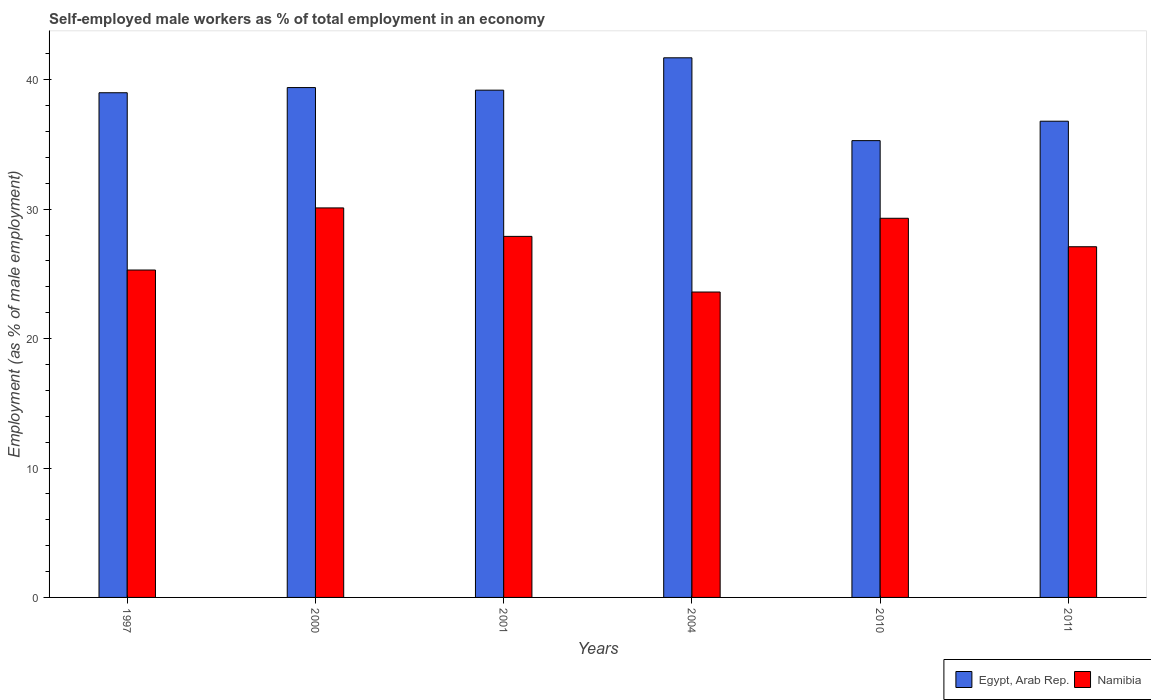How many different coloured bars are there?
Ensure brevity in your answer.  2. Are the number of bars per tick equal to the number of legend labels?
Ensure brevity in your answer.  Yes. How many bars are there on the 1st tick from the left?
Offer a terse response. 2. How many bars are there on the 2nd tick from the right?
Ensure brevity in your answer.  2. What is the label of the 1st group of bars from the left?
Ensure brevity in your answer.  1997. What is the percentage of self-employed male workers in Egypt, Arab Rep. in 2001?
Offer a terse response. 39.2. Across all years, what is the maximum percentage of self-employed male workers in Egypt, Arab Rep.?
Your response must be concise. 41.7. Across all years, what is the minimum percentage of self-employed male workers in Namibia?
Your answer should be very brief. 23.6. What is the total percentage of self-employed male workers in Namibia in the graph?
Offer a terse response. 163.3. What is the difference between the percentage of self-employed male workers in Namibia in 2011 and the percentage of self-employed male workers in Egypt, Arab Rep. in 2010?
Your answer should be very brief. -8.2. What is the average percentage of self-employed male workers in Namibia per year?
Ensure brevity in your answer.  27.22. In the year 2001, what is the difference between the percentage of self-employed male workers in Egypt, Arab Rep. and percentage of self-employed male workers in Namibia?
Provide a short and direct response. 11.3. What is the ratio of the percentage of self-employed male workers in Egypt, Arab Rep. in 2004 to that in 2011?
Offer a terse response. 1.13. Is the percentage of self-employed male workers in Namibia in 1997 less than that in 2010?
Your response must be concise. Yes. Is the difference between the percentage of self-employed male workers in Egypt, Arab Rep. in 1997 and 2004 greater than the difference between the percentage of self-employed male workers in Namibia in 1997 and 2004?
Give a very brief answer. No. What is the difference between the highest and the second highest percentage of self-employed male workers in Namibia?
Your response must be concise. 0.8. What is the difference between the highest and the lowest percentage of self-employed male workers in Namibia?
Your response must be concise. 6.5. In how many years, is the percentage of self-employed male workers in Egypt, Arab Rep. greater than the average percentage of self-employed male workers in Egypt, Arab Rep. taken over all years?
Offer a very short reply. 4. Is the sum of the percentage of self-employed male workers in Namibia in 2000 and 2010 greater than the maximum percentage of self-employed male workers in Egypt, Arab Rep. across all years?
Provide a short and direct response. Yes. What does the 1st bar from the left in 2000 represents?
Keep it short and to the point. Egypt, Arab Rep. What does the 2nd bar from the right in 1997 represents?
Make the answer very short. Egypt, Arab Rep. How many bars are there?
Make the answer very short. 12. How many years are there in the graph?
Your answer should be very brief. 6. Where does the legend appear in the graph?
Offer a terse response. Bottom right. How are the legend labels stacked?
Give a very brief answer. Horizontal. What is the title of the graph?
Ensure brevity in your answer.  Self-employed male workers as % of total employment in an economy. What is the label or title of the X-axis?
Keep it short and to the point. Years. What is the label or title of the Y-axis?
Your response must be concise. Employment (as % of male employment). What is the Employment (as % of male employment) in Egypt, Arab Rep. in 1997?
Offer a very short reply. 39. What is the Employment (as % of male employment) in Namibia in 1997?
Give a very brief answer. 25.3. What is the Employment (as % of male employment) of Egypt, Arab Rep. in 2000?
Offer a terse response. 39.4. What is the Employment (as % of male employment) of Namibia in 2000?
Your response must be concise. 30.1. What is the Employment (as % of male employment) of Egypt, Arab Rep. in 2001?
Your answer should be very brief. 39.2. What is the Employment (as % of male employment) in Namibia in 2001?
Make the answer very short. 27.9. What is the Employment (as % of male employment) of Egypt, Arab Rep. in 2004?
Offer a very short reply. 41.7. What is the Employment (as % of male employment) in Namibia in 2004?
Offer a terse response. 23.6. What is the Employment (as % of male employment) in Egypt, Arab Rep. in 2010?
Make the answer very short. 35.3. What is the Employment (as % of male employment) in Namibia in 2010?
Keep it short and to the point. 29.3. What is the Employment (as % of male employment) in Egypt, Arab Rep. in 2011?
Offer a terse response. 36.8. What is the Employment (as % of male employment) of Namibia in 2011?
Give a very brief answer. 27.1. Across all years, what is the maximum Employment (as % of male employment) of Egypt, Arab Rep.?
Offer a very short reply. 41.7. Across all years, what is the maximum Employment (as % of male employment) in Namibia?
Offer a terse response. 30.1. Across all years, what is the minimum Employment (as % of male employment) in Egypt, Arab Rep.?
Ensure brevity in your answer.  35.3. Across all years, what is the minimum Employment (as % of male employment) of Namibia?
Give a very brief answer. 23.6. What is the total Employment (as % of male employment) in Egypt, Arab Rep. in the graph?
Provide a succinct answer. 231.4. What is the total Employment (as % of male employment) in Namibia in the graph?
Offer a very short reply. 163.3. What is the difference between the Employment (as % of male employment) in Namibia in 1997 and that in 2000?
Your answer should be compact. -4.8. What is the difference between the Employment (as % of male employment) in Egypt, Arab Rep. in 1997 and that in 2001?
Offer a very short reply. -0.2. What is the difference between the Employment (as % of male employment) in Namibia in 1997 and that in 2001?
Give a very brief answer. -2.6. What is the difference between the Employment (as % of male employment) in Egypt, Arab Rep. in 1997 and that in 2004?
Your response must be concise. -2.7. What is the difference between the Employment (as % of male employment) in Egypt, Arab Rep. in 1997 and that in 2010?
Provide a short and direct response. 3.7. What is the difference between the Employment (as % of male employment) in Egypt, Arab Rep. in 1997 and that in 2011?
Provide a succinct answer. 2.2. What is the difference between the Employment (as % of male employment) in Egypt, Arab Rep. in 2000 and that in 2004?
Make the answer very short. -2.3. What is the difference between the Employment (as % of male employment) in Namibia in 2000 and that in 2004?
Offer a terse response. 6.5. What is the difference between the Employment (as % of male employment) in Namibia in 2000 and that in 2010?
Offer a terse response. 0.8. What is the difference between the Employment (as % of male employment) of Namibia in 2000 and that in 2011?
Provide a succinct answer. 3. What is the difference between the Employment (as % of male employment) of Namibia in 2001 and that in 2004?
Keep it short and to the point. 4.3. What is the difference between the Employment (as % of male employment) in Egypt, Arab Rep. in 2001 and that in 2010?
Keep it short and to the point. 3.9. What is the difference between the Employment (as % of male employment) in Namibia in 2001 and that in 2010?
Make the answer very short. -1.4. What is the difference between the Employment (as % of male employment) in Egypt, Arab Rep. in 2001 and that in 2011?
Ensure brevity in your answer.  2.4. What is the difference between the Employment (as % of male employment) in Namibia in 2001 and that in 2011?
Make the answer very short. 0.8. What is the difference between the Employment (as % of male employment) in Namibia in 2004 and that in 2011?
Offer a very short reply. -3.5. What is the difference between the Employment (as % of male employment) of Egypt, Arab Rep. in 1997 and the Employment (as % of male employment) of Namibia in 2001?
Offer a terse response. 11.1. What is the difference between the Employment (as % of male employment) of Egypt, Arab Rep. in 1997 and the Employment (as % of male employment) of Namibia in 2004?
Offer a terse response. 15.4. What is the difference between the Employment (as % of male employment) of Egypt, Arab Rep. in 2000 and the Employment (as % of male employment) of Namibia in 2004?
Provide a succinct answer. 15.8. What is the difference between the Employment (as % of male employment) in Egypt, Arab Rep. in 2000 and the Employment (as % of male employment) in Namibia in 2010?
Give a very brief answer. 10.1. What is the difference between the Employment (as % of male employment) of Egypt, Arab Rep. in 2000 and the Employment (as % of male employment) of Namibia in 2011?
Ensure brevity in your answer.  12.3. What is the difference between the Employment (as % of male employment) of Egypt, Arab Rep. in 2001 and the Employment (as % of male employment) of Namibia in 2011?
Provide a short and direct response. 12.1. What is the difference between the Employment (as % of male employment) in Egypt, Arab Rep. in 2004 and the Employment (as % of male employment) in Namibia in 2010?
Your answer should be compact. 12.4. What is the difference between the Employment (as % of male employment) in Egypt, Arab Rep. in 2004 and the Employment (as % of male employment) in Namibia in 2011?
Make the answer very short. 14.6. What is the average Employment (as % of male employment) in Egypt, Arab Rep. per year?
Your answer should be very brief. 38.57. What is the average Employment (as % of male employment) in Namibia per year?
Give a very brief answer. 27.22. In the year 2010, what is the difference between the Employment (as % of male employment) in Egypt, Arab Rep. and Employment (as % of male employment) in Namibia?
Keep it short and to the point. 6. What is the ratio of the Employment (as % of male employment) in Namibia in 1997 to that in 2000?
Your answer should be compact. 0.84. What is the ratio of the Employment (as % of male employment) of Egypt, Arab Rep. in 1997 to that in 2001?
Offer a terse response. 0.99. What is the ratio of the Employment (as % of male employment) in Namibia in 1997 to that in 2001?
Offer a very short reply. 0.91. What is the ratio of the Employment (as % of male employment) in Egypt, Arab Rep. in 1997 to that in 2004?
Give a very brief answer. 0.94. What is the ratio of the Employment (as % of male employment) of Namibia in 1997 to that in 2004?
Give a very brief answer. 1.07. What is the ratio of the Employment (as % of male employment) in Egypt, Arab Rep. in 1997 to that in 2010?
Provide a short and direct response. 1.1. What is the ratio of the Employment (as % of male employment) in Namibia in 1997 to that in 2010?
Your response must be concise. 0.86. What is the ratio of the Employment (as % of male employment) in Egypt, Arab Rep. in 1997 to that in 2011?
Make the answer very short. 1.06. What is the ratio of the Employment (as % of male employment) of Namibia in 1997 to that in 2011?
Offer a terse response. 0.93. What is the ratio of the Employment (as % of male employment) of Namibia in 2000 to that in 2001?
Offer a terse response. 1.08. What is the ratio of the Employment (as % of male employment) in Egypt, Arab Rep. in 2000 to that in 2004?
Provide a succinct answer. 0.94. What is the ratio of the Employment (as % of male employment) of Namibia in 2000 to that in 2004?
Ensure brevity in your answer.  1.28. What is the ratio of the Employment (as % of male employment) in Egypt, Arab Rep. in 2000 to that in 2010?
Provide a short and direct response. 1.12. What is the ratio of the Employment (as % of male employment) in Namibia in 2000 to that in 2010?
Ensure brevity in your answer.  1.03. What is the ratio of the Employment (as % of male employment) of Egypt, Arab Rep. in 2000 to that in 2011?
Make the answer very short. 1.07. What is the ratio of the Employment (as % of male employment) of Namibia in 2000 to that in 2011?
Offer a very short reply. 1.11. What is the ratio of the Employment (as % of male employment) in Egypt, Arab Rep. in 2001 to that in 2004?
Your answer should be compact. 0.94. What is the ratio of the Employment (as % of male employment) in Namibia in 2001 to that in 2004?
Offer a very short reply. 1.18. What is the ratio of the Employment (as % of male employment) of Egypt, Arab Rep. in 2001 to that in 2010?
Offer a terse response. 1.11. What is the ratio of the Employment (as % of male employment) of Namibia in 2001 to that in 2010?
Your answer should be compact. 0.95. What is the ratio of the Employment (as % of male employment) in Egypt, Arab Rep. in 2001 to that in 2011?
Make the answer very short. 1.07. What is the ratio of the Employment (as % of male employment) in Namibia in 2001 to that in 2011?
Make the answer very short. 1.03. What is the ratio of the Employment (as % of male employment) in Egypt, Arab Rep. in 2004 to that in 2010?
Offer a very short reply. 1.18. What is the ratio of the Employment (as % of male employment) of Namibia in 2004 to that in 2010?
Ensure brevity in your answer.  0.81. What is the ratio of the Employment (as % of male employment) in Egypt, Arab Rep. in 2004 to that in 2011?
Your response must be concise. 1.13. What is the ratio of the Employment (as % of male employment) in Namibia in 2004 to that in 2011?
Keep it short and to the point. 0.87. What is the ratio of the Employment (as % of male employment) in Egypt, Arab Rep. in 2010 to that in 2011?
Your answer should be very brief. 0.96. What is the ratio of the Employment (as % of male employment) of Namibia in 2010 to that in 2011?
Provide a short and direct response. 1.08. What is the difference between the highest and the lowest Employment (as % of male employment) of Egypt, Arab Rep.?
Ensure brevity in your answer.  6.4. What is the difference between the highest and the lowest Employment (as % of male employment) of Namibia?
Give a very brief answer. 6.5. 